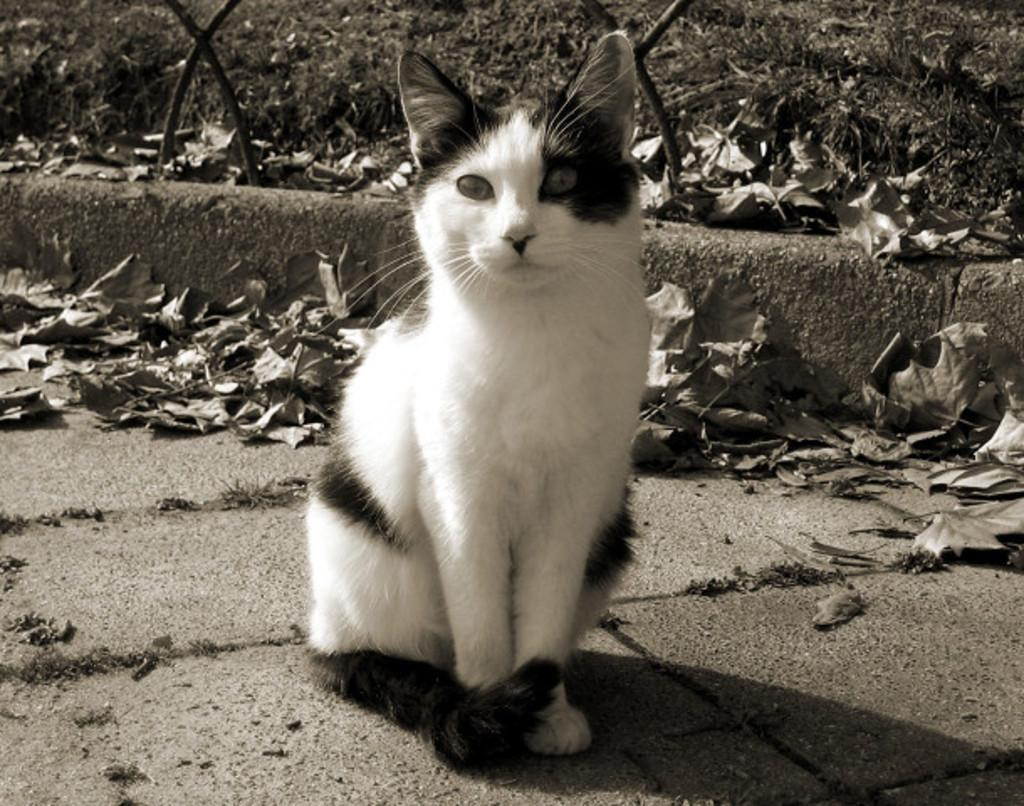What is the color scheme of the image? The image is black and white. What animal can be seen in the center of the image? There is a cat sitting on the ground in the center of the image. What type of vegetation is present in the background of the image? Dry leaves and plants are present in the background of the image. What other objects can be seen in the background of the image? Rods are visible in the background of the image. Can you tell me how many books are stacked on the seashore in the image? There is no seashore or books present in the image; it features a cat sitting on the ground in a black and white setting with dry leaves, plants, and rods in the background. 